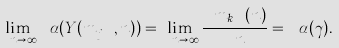Convert formula to latex. <formula><loc_0><loc_0><loc_500><loc_500>\lim _ { \ n \rightarrow \infty } { \ \alpha ( Y ( m } _ { j } { \ , n ) ) } = \lim _ { \ n \rightarrow \infty } \frac { { \ m } _ { k } { \ ( n ) } } { \ n } = { \ \alpha ( \gamma ) . \ }</formula> 